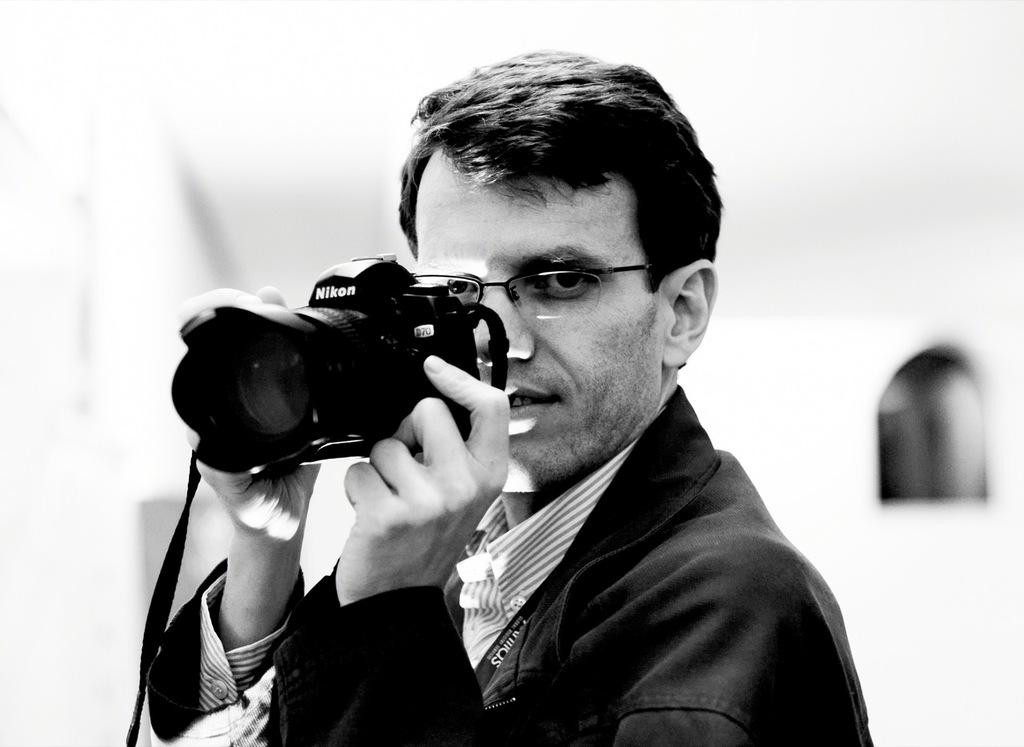What is the color scheme of the image? The image is black and white. Who is present in the image? There is a man in the image. What is the man holding in his hand? The man is holding a camera in his hand. What accessory is the man wearing? The man is wearing spectacles. Can you describe the background of the image? The background of the image is blurry. What type of flight is the man taking in the image? There is no flight present in the image; it is a man holding a camera and wearing spectacles in a blurry background. How does the man show respect to the structure in the image? There is no structure present in the image, and the man's actions cannot be determined based on the provided facts. 